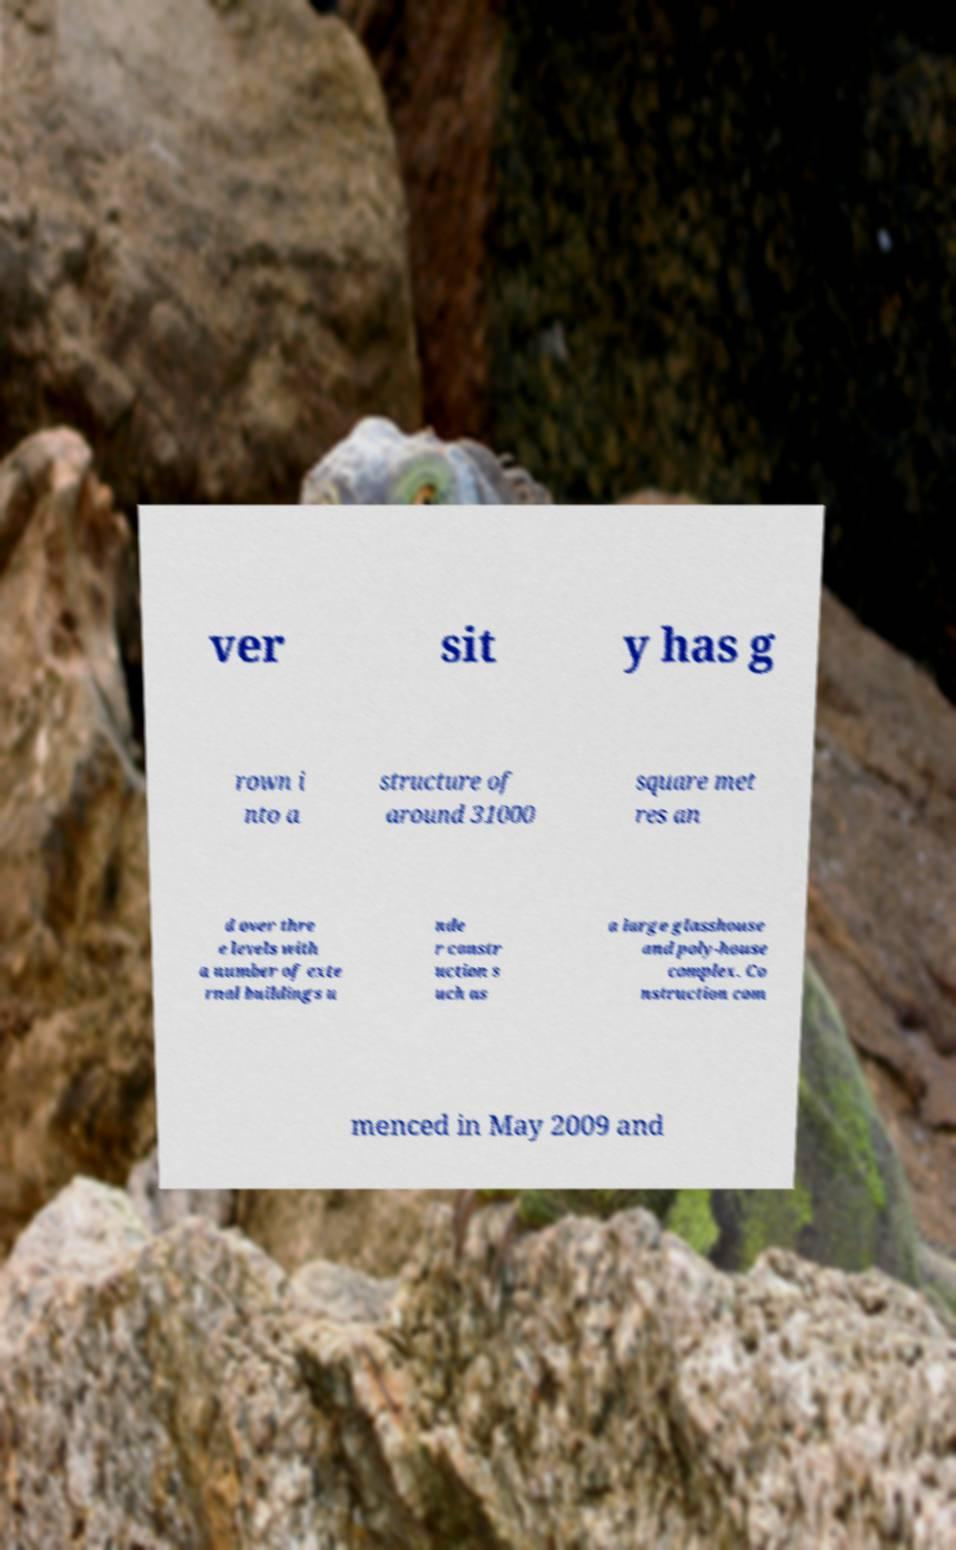Can you read and provide the text displayed in the image?This photo seems to have some interesting text. Can you extract and type it out for me? ver sit y has g rown i nto a structure of around 31000 square met res an d over thre e levels with a number of exte rnal buildings u nde r constr uction s uch as a large glasshouse and poly-house complex. Co nstruction com menced in May 2009 and 